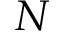<formula> <loc_0><loc_0><loc_500><loc_500>N</formula> 